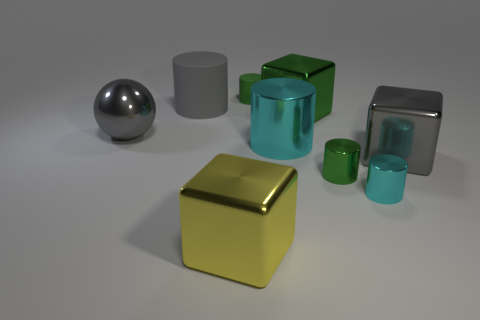What shape is the tiny green object in front of the gray metal object on the left side of the tiny green object in front of the ball?
Make the answer very short. Cylinder. Does the yellow thing have the same size as the green cylinder right of the tiny rubber object?
Offer a very short reply. No. The small cylinder that is in front of the gray rubber object and to the left of the small cyan metal cylinder is what color?
Give a very brief answer. Green. How many other things are the same shape as the small green rubber object?
Provide a short and direct response. 4. Is the color of the shiny sphere behind the green shiny cylinder the same as the cylinder that is on the left side of the yellow cube?
Your answer should be very brief. Yes. There is a object that is in front of the small cyan object; is its size the same as the cube that is behind the big gray metallic cube?
Offer a terse response. Yes. There is a tiny green thing that is behind the big cylinder that is right of the small green cylinder that is behind the large cyan metal cylinder; what is its material?
Keep it short and to the point. Rubber. Is the shape of the tiny green metallic object the same as the yellow metallic object?
Provide a short and direct response. No. There is a big gray thing that is the same shape as the yellow shiny object; what material is it?
Offer a terse response. Metal. What number of large matte objects are the same color as the metal sphere?
Offer a terse response. 1. 